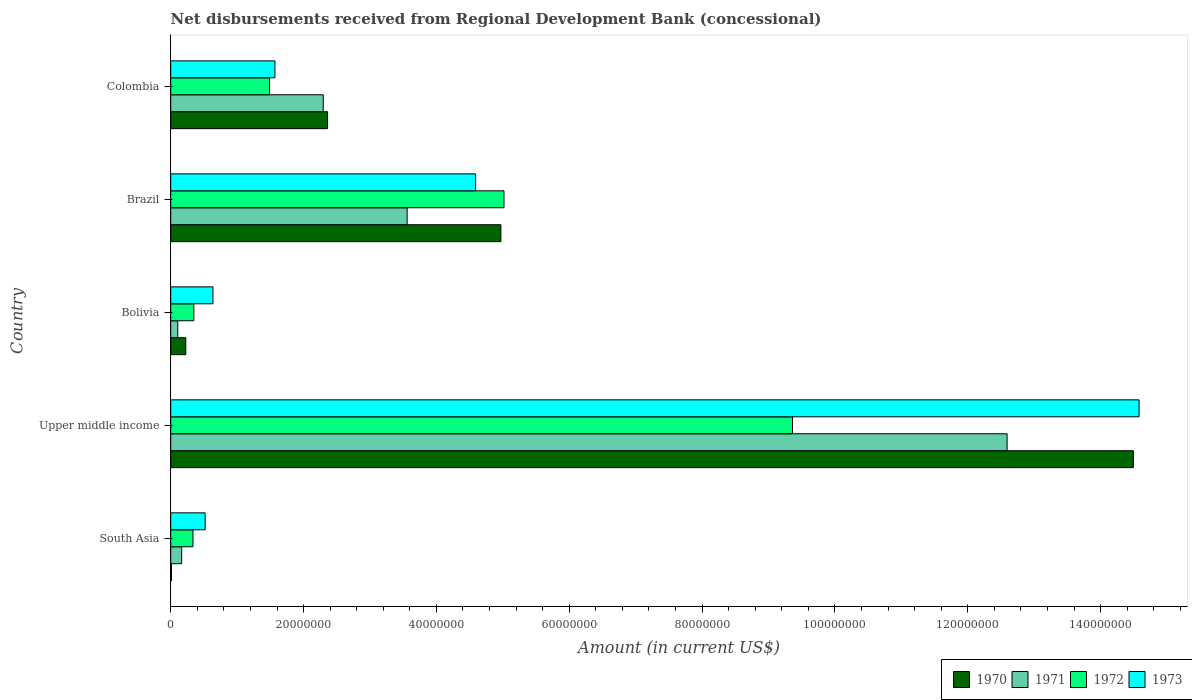Are the number of bars per tick equal to the number of legend labels?
Provide a succinct answer. Yes. Are the number of bars on each tick of the Y-axis equal?
Your answer should be very brief. Yes. What is the label of the 4th group of bars from the top?
Keep it short and to the point. Upper middle income. In how many cases, is the number of bars for a given country not equal to the number of legend labels?
Offer a very short reply. 0. What is the amount of disbursements received from Regional Development Bank in 1970 in Colombia?
Offer a terse response. 2.36e+07. Across all countries, what is the maximum amount of disbursements received from Regional Development Bank in 1970?
Your answer should be compact. 1.45e+08. Across all countries, what is the minimum amount of disbursements received from Regional Development Bank in 1971?
Offer a terse response. 1.06e+06. In which country was the amount of disbursements received from Regional Development Bank in 1973 maximum?
Ensure brevity in your answer.  Upper middle income. What is the total amount of disbursements received from Regional Development Bank in 1973 in the graph?
Keep it short and to the point. 2.19e+08. What is the difference between the amount of disbursements received from Regional Development Bank in 1970 in Bolivia and that in Brazil?
Provide a short and direct response. -4.74e+07. What is the difference between the amount of disbursements received from Regional Development Bank in 1971 in South Asia and the amount of disbursements received from Regional Development Bank in 1972 in Colombia?
Make the answer very short. -1.32e+07. What is the average amount of disbursements received from Regional Development Bank in 1972 per country?
Offer a terse response. 3.31e+07. What is the difference between the amount of disbursements received from Regional Development Bank in 1970 and amount of disbursements received from Regional Development Bank in 1972 in Brazil?
Your response must be concise. -4.68e+05. In how many countries, is the amount of disbursements received from Regional Development Bank in 1970 greater than 72000000 US$?
Provide a short and direct response. 1. What is the ratio of the amount of disbursements received from Regional Development Bank in 1971 in Colombia to that in Upper middle income?
Ensure brevity in your answer.  0.18. Is the amount of disbursements received from Regional Development Bank in 1970 in Bolivia less than that in Brazil?
Offer a terse response. Yes. What is the difference between the highest and the second highest amount of disbursements received from Regional Development Bank in 1970?
Your answer should be compact. 9.52e+07. What is the difference between the highest and the lowest amount of disbursements received from Regional Development Bank in 1971?
Your response must be concise. 1.25e+08. Is the sum of the amount of disbursements received from Regional Development Bank in 1973 in South Asia and Upper middle income greater than the maximum amount of disbursements received from Regional Development Bank in 1971 across all countries?
Keep it short and to the point. Yes. Is it the case that in every country, the sum of the amount of disbursements received from Regional Development Bank in 1971 and amount of disbursements received from Regional Development Bank in 1972 is greater than the sum of amount of disbursements received from Regional Development Bank in 1973 and amount of disbursements received from Regional Development Bank in 1970?
Provide a short and direct response. No. What does the 4th bar from the top in Brazil represents?
Make the answer very short. 1970. How many bars are there?
Ensure brevity in your answer.  20. Are all the bars in the graph horizontal?
Your response must be concise. Yes. How many countries are there in the graph?
Provide a succinct answer. 5. Does the graph contain any zero values?
Give a very brief answer. No. How many legend labels are there?
Offer a very short reply. 4. How are the legend labels stacked?
Your response must be concise. Horizontal. What is the title of the graph?
Ensure brevity in your answer.  Net disbursements received from Regional Development Bank (concessional). Does "1983" appear as one of the legend labels in the graph?
Provide a succinct answer. No. What is the label or title of the Y-axis?
Offer a very short reply. Country. What is the Amount (in current US$) of 1970 in South Asia?
Give a very brief answer. 1.09e+05. What is the Amount (in current US$) of 1971 in South Asia?
Make the answer very short. 1.65e+06. What is the Amount (in current US$) in 1972 in South Asia?
Ensure brevity in your answer.  3.35e+06. What is the Amount (in current US$) of 1973 in South Asia?
Offer a very short reply. 5.18e+06. What is the Amount (in current US$) of 1970 in Upper middle income?
Ensure brevity in your answer.  1.45e+08. What is the Amount (in current US$) in 1971 in Upper middle income?
Offer a terse response. 1.26e+08. What is the Amount (in current US$) of 1972 in Upper middle income?
Provide a succinct answer. 9.36e+07. What is the Amount (in current US$) in 1973 in Upper middle income?
Offer a very short reply. 1.46e+08. What is the Amount (in current US$) of 1970 in Bolivia?
Ensure brevity in your answer.  2.27e+06. What is the Amount (in current US$) of 1971 in Bolivia?
Keep it short and to the point. 1.06e+06. What is the Amount (in current US$) in 1972 in Bolivia?
Your answer should be compact. 3.48e+06. What is the Amount (in current US$) of 1973 in Bolivia?
Your answer should be very brief. 6.36e+06. What is the Amount (in current US$) in 1970 in Brazil?
Provide a succinct answer. 4.97e+07. What is the Amount (in current US$) in 1971 in Brazil?
Your answer should be compact. 3.56e+07. What is the Amount (in current US$) in 1972 in Brazil?
Make the answer very short. 5.02e+07. What is the Amount (in current US$) of 1973 in Brazil?
Ensure brevity in your answer.  4.59e+07. What is the Amount (in current US$) of 1970 in Colombia?
Your response must be concise. 2.36e+07. What is the Amount (in current US$) of 1971 in Colombia?
Your response must be concise. 2.30e+07. What is the Amount (in current US$) of 1972 in Colombia?
Your answer should be very brief. 1.49e+07. What is the Amount (in current US$) in 1973 in Colombia?
Offer a very short reply. 1.57e+07. Across all countries, what is the maximum Amount (in current US$) in 1970?
Your answer should be compact. 1.45e+08. Across all countries, what is the maximum Amount (in current US$) in 1971?
Ensure brevity in your answer.  1.26e+08. Across all countries, what is the maximum Amount (in current US$) of 1972?
Your response must be concise. 9.36e+07. Across all countries, what is the maximum Amount (in current US$) of 1973?
Your response must be concise. 1.46e+08. Across all countries, what is the minimum Amount (in current US$) of 1970?
Your answer should be very brief. 1.09e+05. Across all countries, what is the minimum Amount (in current US$) in 1971?
Offer a very short reply. 1.06e+06. Across all countries, what is the minimum Amount (in current US$) of 1972?
Provide a short and direct response. 3.35e+06. Across all countries, what is the minimum Amount (in current US$) of 1973?
Your answer should be compact. 5.18e+06. What is the total Amount (in current US$) in 1970 in the graph?
Provide a short and direct response. 2.21e+08. What is the total Amount (in current US$) of 1971 in the graph?
Give a very brief answer. 1.87e+08. What is the total Amount (in current US$) of 1972 in the graph?
Your answer should be very brief. 1.65e+08. What is the total Amount (in current US$) in 1973 in the graph?
Offer a very short reply. 2.19e+08. What is the difference between the Amount (in current US$) in 1970 in South Asia and that in Upper middle income?
Ensure brevity in your answer.  -1.45e+08. What is the difference between the Amount (in current US$) in 1971 in South Asia and that in Upper middle income?
Keep it short and to the point. -1.24e+08. What is the difference between the Amount (in current US$) in 1972 in South Asia and that in Upper middle income?
Keep it short and to the point. -9.03e+07. What is the difference between the Amount (in current US$) of 1973 in South Asia and that in Upper middle income?
Give a very brief answer. -1.41e+08. What is the difference between the Amount (in current US$) in 1970 in South Asia and that in Bolivia?
Make the answer very short. -2.16e+06. What is the difference between the Amount (in current US$) of 1971 in South Asia and that in Bolivia?
Your answer should be compact. 5.92e+05. What is the difference between the Amount (in current US$) of 1973 in South Asia and that in Bolivia?
Make the answer very short. -1.18e+06. What is the difference between the Amount (in current US$) in 1970 in South Asia and that in Brazil?
Provide a short and direct response. -4.96e+07. What is the difference between the Amount (in current US$) of 1971 in South Asia and that in Brazil?
Your answer should be compact. -3.39e+07. What is the difference between the Amount (in current US$) of 1972 in South Asia and that in Brazil?
Offer a terse response. -4.68e+07. What is the difference between the Amount (in current US$) of 1973 in South Asia and that in Brazil?
Your answer should be compact. -4.07e+07. What is the difference between the Amount (in current US$) in 1970 in South Asia and that in Colombia?
Your answer should be very brief. -2.35e+07. What is the difference between the Amount (in current US$) of 1971 in South Asia and that in Colombia?
Make the answer very short. -2.13e+07. What is the difference between the Amount (in current US$) in 1972 in South Asia and that in Colombia?
Keep it short and to the point. -1.15e+07. What is the difference between the Amount (in current US$) of 1973 in South Asia and that in Colombia?
Your answer should be very brief. -1.05e+07. What is the difference between the Amount (in current US$) of 1970 in Upper middle income and that in Bolivia?
Provide a short and direct response. 1.43e+08. What is the difference between the Amount (in current US$) in 1971 in Upper middle income and that in Bolivia?
Your answer should be compact. 1.25e+08. What is the difference between the Amount (in current US$) in 1972 in Upper middle income and that in Bolivia?
Provide a succinct answer. 9.01e+07. What is the difference between the Amount (in current US$) in 1973 in Upper middle income and that in Bolivia?
Your response must be concise. 1.39e+08. What is the difference between the Amount (in current US$) of 1970 in Upper middle income and that in Brazil?
Ensure brevity in your answer.  9.52e+07. What is the difference between the Amount (in current US$) of 1971 in Upper middle income and that in Brazil?
Keep it short and to the point. 9.03e+07. What is the difference between the Amount (in current US$) of 1972 in Upper middle income and that in Brazil?
Provide a short and direct response. 4.34e+07. What is the difference between the Amount (in current US$) of 1973 in Upper middle income and that in Brazil?
Ensure brevity in your answer.  9.99e+07. What is the difference between the Amount (in current US$) of 1970 in Upper middle income and that in Colombia?
Offer a very short reply. 1.21e+08. What is the difference between the Amount (in current US$) of 1971 in Upper middle income and that in Colombia?
Keep it short and to the point. 1.03e+08. What is the difference between the Amount (in current US$) in 1972 in Upper middle income and that in Colombia?
Provide a succinct answer. 7.87e+07. What is the difference between the Amount (in current US$) of 1973 in Upper middle income and that in Colombia?
Your answer should be very brief. 1.30e+08. What is the difference between the Amount (in current US$) of 1970 in Bolivia and that in Brazil?
Offer a very short reply. -4.74e+07. What is the difference between the Amount (in current US$) in 1971 in Bolivia and that in Brazil?
Your answer should be compact. -3.45e+07. What is the difference between the Amount (in current US$) of 1972 in Bolivia and that in Brazil?
Provide a short and direct response. -4.67e+07. What is the difference between the Amount (in current US$) of 1973 in Bolivia and that in Brazil?
Make the answer very short. -3.95e+07. What is the difference between the Amount (in current US$) in 1970 in Bolivia and that in Colombia?
Offer a terse response. -2.13e+07. What is the difference between the Amount (in current US$) of 1971 in Bolivia and that in Colombia?
Your response must be concise. -2.19e+07. What is the difference between the Amount (in current US$) in 1972 in Bolivia and that in Colombia?
Offer a very short reply. -1.14e+07. What is the difference between the Amount (in current US$) of 1973 in Bolivia and that in Colombia?
Offer a terse response. -9.33e+06. What is the difference between the Amount (in current US$) in 1970 in Brazil and that in Colombia?
Make the answer very short. 2.61e+07. What is the difference between the Amount (in current US$) of 1971 in Brazil and that in Colombia?
Ensure brevity in your answer.  1.26e+07. What is the difference between the Amount (in current US$) in 1972 in Brazil and that in Colombia?
Your answer should be very brief. 3.53e+07. What is the difference between the Amount (in current US$) of 1973 in Brazil and that in Colombia?
Offer a very short reply. 3.02e+07. What is the difference between the Amount (in current US$) of 1970 in South Asia and the Amount (in current US$) of 1971 in Upper middle income?
Make the answer very short. -1.26e+08. What is the difference between the Amount (in current US$) of 1970 in South Asia and the Amount (in current US$) of 1972 in Upper middle income?
Give a very brief answer. -9.35e+07. What is the difference between the Amount (in current US$) in 1970 in South Asia and the Amount (in current US$) in 1973 in Upper middle income?
Make the answer very short. -1.46e+08. What is the difference between the Amount (in current US$) of 1971 in South Asia and the Amount (in current US$) of 1972 in Upper middle income?
Your answer should be very brief. -9.20e+07. What is the difference between the Amount (in current US$) of 1971 in South Asia and the Amount (in current US$) of 1973 in Upper middle income?
Give a very brief answer. -1.44e+08. What is the difference between the Amount (in current US$) in 1972 in South Asia and the Amount (in current US$) in 1973 in Upper middle income?
Ensure brevity in your answer.  -1.42e+08. What is the difference between the Amount (in current US$) of 1970 in South Asia and the Amount (in current US$) of 1971 in Bolivia?
Provide a short and direct response. -9.49e+05. What is the difference between the Amount (in current US$) in 1970 in South Asia and the Amount (in current US$) in 1972 in Bolivia?
Your answer should be compact. -3.37e+06. What is the difference between the Amount (in current US$) of 1970 in South Asia and the Amount (in current US$) of 1973 in Bolivia?
Provide a succinct answer. -6.25e+06. What is the difference between the Amount (in current US$) in 1971 in South Asia and the Amount (in current US$) in 1972 in Bolivia?
Provide a short and direct response. -1.83e+06. What is the difference between the Amount (in current US$) of 1971 in South Asia and the Amount (in current US$) of 1973 in Bolivia?
Offer a terse response. -4.71e+06. What is the difference between the Amount (in current US$) of 1972 in South Asia and the Amount (in current US$) of 1973 in Bolivia?
Ensure brevity in your answer.  -3.01e+06. What is the difference between the Amount (in current US$) of 1970 in South Asia and the Amount (in current US$) of 1971 in Brazil?
Your response must be concise. -3.55e+07. What is the difference between the Amount (in current US$) in 1970 in South Asia and the Amount (in current US$) in 1972 in Brazil?
Provide a succinct answer. -5.01e+07. What is the difference between the Amount (in current US$) in 1970 in South Asia and the Amount (in current US$) in 1973 in Brazil?
Offer a terse response. -4.58e+07. What is the difference between the Amount (in current US$) of 1971 in South Asia and the Amount (in current US$) of 1972 in Brazil?
Offer a very short reply. -4.85e+07. What is the difference between the Amount (in current US$) of 1971 in South Asia and the Amount (in current US$) of 1973 in Brazil?
Provide a short and direct response. -4.43e+07. What is the difference between the Amount (in current US$) in 1972 in South Asia and the Amount (in current US$) in 1973 in Brazil?
Provide a short and direct response. -4.26e+07. What is the difference between the Amount (in current US$) in 1970 in South Asia and the Amount (in current US$) in 1971 in Colombia?
Ensure brevity in your answer.  -2.29e+07. What is the difference between the Amount (in current US$) in 1970 in South Asia and the Amount (in current US$) in 1972 in Colombia?
Your response must be concise. -1.48e+07. What is the difference between the Amount (in current US$) of 1970 in South Asia and the Amount (in current US$) of 1973 in Colombia?
Your answer should be very brief. -1.56e+07. What is the difference between the Amount (in current US$) of 1971 in South Asia and the Amount (in current US$) of 1972 in Colombia?
Ensure brevity in your answer.  -1.32e+07. What is the difference between the Amount (in current US$) in 1971 in South Asia and the Amount (in current US$) in 1973 in Colombia?
Ensure brevity in your answer.  -1.40e+07. What is the difference between the Amount (in current US$) in 1972 in South Asia and the Amount (in current US$) in 1973 in Colombia?
Provide a succinct answer. -1.23e+07. What is the difference between the Amount (in current US$) of 1970 in Upper middle income and the Amount (in current US$) of 1971 in Bolivia?
Offer a very short reply. 1.44e+08. What is the difference between the Amount (in current US$) in 1970 in Upper middle income and the Amount (in current US$) in 1972 in Bolivia?
Your answer should be very brief. 1.41e+08. What is the difference between the Amount (in current US$) in 1970 in Upper middle income and the Amount (in current US$) in 1973 in Bolivia?
Make the answer very short. 1.39e+08. What is the difference between the Amount (in current US$) in 1971 in Upper middle income and the Amount (in current US$) in 1972 in Bolivia?
Your response must be concise. 1.22e+08. What is the difference between the Amount (in current US$) of 1971 in Upper middle income and the Amount (in current US$) of 1973 in Bolivia?
Make the answer very short. 1.20e+08. What is the difference between the Amount (in current US$) of 1972 in Upper middle income and the Amount (in current US$) of 1973 in Bolivia?
Offer a terse response. 8.72e+07. What is the difference between the Amount (in current US$) of 1970 in Upper middle income and the Amount (in current US$) of 1971 in Brazil?
Your answer should be very brief. 1.09e+08. What is the difference between the Amount (in current US$) of 1970 in Upper middle income and the Amount (in current US$) of 1972 in Brazil?
Give a very brief answer. 9.48e+07. What is the difference between the Amount (in current US$) of 1970 in Upper middle income and the Amount (in current US$) of 1973 in Brazil?
Offer a very short reply. 9.90e+07. What is the difference between the Amount (in current US$) of 1971 in Upper middle income and the Amount (in current US$) of 1972 in Brazil?
Provide a succinct answer. 7.57e+07. What is the difference between the Amount (in current US$) in 1971 in Upper middle income and the Amount (in current US$) in 1973 in Brazil?
Your answer should be compact. 8.00e+07. What is the difference between the Amount (in current US$) in 1972 in Upper middle income and the Amount (in current US$) in 1973 in Brazil?
Make the answer very short. 4.77e+07. What is the difference between the Amount (in current US$) of 1970 in Upper middle income and the Amount (in current US$) of 1971 in Colombia?
Give a very brief answer. 1.22e+08. What is the difference between the Amount (in current US$) in 1970 in Upper middle income and the Amount (in current US$) in 1972 in Colombia?
Give a very brief answer. 1.30e+08. What is the difference between the Amount (in current US$) in 1970 in Upper middle income and the Amount (in current US$) in 1973 in Colombia?
Your answer should be very brief. 1.29e+08. What is the difference between the Amount (in current US$) in 1971 in Upper middle income and the Amount (in current US$) in 1972 in Colombia?
Offer a terse response. 1.11e+08. What is the difference between the Amount (in current US$) of 1971 in Upper middle income and the Amount (in current US$) of 1973 in Colombia?
Offer a very short reply. 1.10e+08. What is the difference between the Amount (in current US$) in 1972 in Upper middle income and the Amount (in current US$) in 1973 in Colombia?
Ensure brevity in your answer.  7.79e+07. What is the difference between the Amount (in current US$) in 1970 in Bolivia and the Amount (in current US$) in 1971 in Brazil?
Offer a terse response. -3.33e+07. What is the difference between the Amount (in current US$) of 1970 in Bolivia and the Amount (in current US$) of 1972 in Brazil?
Give a very brief answer. -4.79e+07. What is the difference between the Amount (in current US$) in 1970 in Bolivia and the Amount (in current US$) in 1973 in Brazil?
Make the answer very short. -4.36e+07. What is the difference between the Amount (in current US$) in 1971 in Bolivia and the Amount (in current US$) in 1972 in Brazil?
Make the answer very short. -4.91e+07. What is the difference between the Amount (in current US$) in 1971 in Bolivia and the Amount (in current US$) in 1973 in Brazil?
Give a very brief answer. -4.49e+07. What is the difference between the Amount (in current US$) of 1972 in Bolivia and the Amount (in current US$) of 1973 in Brazil?
Your answer should be very brief. -4.24e+07. What is the difference between the Amount (in current US$) of 1970 in Bolivia and the Amount (in current US$) of 1971 in Colombia?
Ensure brevity in your answer.  -2.07e+07. What is the difference between the Amount (in current US$) of 1970 in Bolivia and the Amount (in current US$) of 1972 in Colombia?
Ensure brevity in your answer.  -1.26e+07. What is the difference between the Amount (in current US$) in 1970 in Bolivia and the Amount (in current US$) in 1973 in Colombia?
Give a very brief answer. -1.34e+07. What is the difference between the Amount (in current US$) of 1971 in Bolivia and the Amount (in current US$) of 1972 in Colombia?
Your answer should be compact. -1.38e+07. What is the difference between the Amount (in current US$) in 1971 in Bolivia and the Amount (in current US$) in 1973 in Colombia?
Make the answer very short. -1.46e+07. What is the difference between the Amount (in current US$) in 1972 in Bolivia and the Amount (in current US$) in 1973 in Colombia?
Ensure brevity in your answer.  -1.22e+07. What is the difference between the Amount (in current US$) in 1970 in Brazil and the Amount (in current US$) in 1971 in Colombia?
Provide a succinct answer. 2.67e+07. What is the difference between the Amount (in current US$) in 1970 in Brazil and the Amount (in current US$) in 1972 in Colombia?
Your response must be concise. 3.48e+07. What is the difference between the Amount (in current US$) in 1970 in Brazil and the Amount (in current US$) in 1973 in Colombia?
Ensure brevity in your answer.  3.40e+07. What is the difference between the Amount (in current US$) of 1971 in Brazil and the Amount (in current US$) of 1972 in Colombia?
Give a very brief answer. 2.07e+07. What is the difference between the Amount (in current US$) in 1971 in Brazil and the Amount (in current US$) in 1973 in Colombia?
Provide a short and direct response. 1.99e+07. What is the difference between the Amount (in current US$) of 1972 in Brazil and the Amount (in current US$) of 1973 in Colombia?
Offer a very short reply. 3.45e+07. What is the average Amount (in current US$) of 1970 per country?
Your answer should be very brief. 4.41e+07. What is the average Amount (in current US$) in 1971 per country?
Ensure brevity in your answer.  3.74e+07. What is the average Amount (in current US$) in 1972 per country?
Your answer should be compact. 3.31e+07. What is the average Amount (in current US$) in 1973 per country?
Your response must be concise. 4.38e+07. What is the difference between the Amount (in current US$) in 1970 and Amount (in current US$) in 1971 in South Asia?
Give a very brief answer. -1.54e+06. What is the difference between the Amount (in current US$) of 1970 and Amount (in current US$) of 1972 in South Asia?
Make the answer very short. -3.24e+06. What is the difference between the Amount (in current US$) in 1970 and Amount (in current US$) in 1973 in South Asia?
Offer a very short reply. -5.08e+06. What is the difference between the Amount (in current US$) in 1971 and Amount (in current US$) in 1972 in South Asia?
Make the answer very short. -1.70e+06. What is the difference between the Amount (in current US$) of 1971 and Amount (in current US$) of 1973 in South Asia?
Your answer should be compact. -3.53e+06. What is the difference between the Amount (in current US$) in 1972 and Amount (in current US$) in 1973 in South Asia?
Keep it short and to the point. -1.83e+06. What is the difference between the Amount (in current US$) in 1970 and Amount (in current US$) in 1971 in Upper middle income?
Make the answer very short. 1.90e+07. What is the difference between the Amount (in current US$) in 1970 and Amount (in current US$) in 1972 in Upper middle income?
Provide a succinct answer. 5.13e+07. What is the difference between the Amount (in current US$) of 1970 and Amount (in current US$) of 1973 in Upper middle income?
Your answer should be very brief. -8.58e+05. What is the difference between the Amount (in current US$) of 1971 and Amount (in current US$) of 1972 in Upper middle income?
Provide a short and direct response. 3.23e+07. What is the difference between the Amount (in current US$) in 1971 and Amount (in current US$) in 1973 in Upper middle income?
Offer a terse response. -1.99e+07. What is the difference between the Amount (in current US$) in 1972 and Amount (in current US$) in 1973 in Upper middle income?
Ensure brevity in your answer.  -5.22e+07. What is the difference between the Amount (in current US$) in 1970 and Amount (in current US$) in 1971 in Bolivia?
Your answer should be very brief. 1.21e+06. What is the difference between the Amount (in current US$) in 1970 and Amount (in current US$) in 1972 in Bolivia?
Provide a succinct answer. -1.21e+06. What is the difference between the Amount (in current US$) of 1970 and Amount (in current US$) of 1973 in Bolivia?
Your answer should be compact. -4.09e+06. What is the difference between the Amount (in current US$) of 1971 and Amount (in current US$) of 1972 in Bolivia?
Keep it short and to the point. -2.42e+06. What is the difference between the Amount (in current US$) in 1971 and Amount (in current US$) in 1973 in Bolivia?
Keep it short and to the point. -5.30e+06. What is the difference between the Amount (in current US$) of 1972 and Amount (in current US$) of 1973 in Bolivia?
Keep it short and to the point. -2.88e+06. What is the difference between the Amount (in current US$) of 1970 and Amount (in current US$) of 1971 in Brazil?
Provide a succinct answer. 1.41e+07. What is the difference between the Amount (in current US$) in 1970 and Amount (in current US$) in 1972 in Brazil?
Ensure brevity in your answer.  -4.68e+05. What is the difference between the Amount (in current US$) in 1970 and Amount (in current US$) in 1973 in Brazil?
Keep it short and to the point. 3.80e+06. What is the difference between the Amount (in current US$) in 1971 and Amount (in current US$) in 1972 in Brazil?
Give a very brief answer. -1.46e+07. What is the difference between the Amount (in current US$) in 1971 and Amount (in current US$) in 1973 in Brazil?
Keep it short and to the point. -1.03e+07. What is the difference between the Amount (in current US$) in 1972 and Amount (in current US$) in 1973 in Brazil?
Make the answer very short. 4.27e+06. What is the difference between the Amount (in current US$) of 1970 and Amount (in current US$) of 1971 in Colombia?
Your answer should be compact. 6.52e+05. What is the difference between the Amount (in current US$) of 1970 and Amount (in current US$) of 1972 in Colombia?
Your response must be concise. 8.74e+06. What is the difference between the Amount (in current US$) in 1970 and Amount (in current US$) in 1973 in Colombia?
Give a very brief answer. 7.93e+06. What is the difference between the Amount (in current US$) in 1971 and Amount (in current US$) in 1972 in Colombia?
Make the answer very short. 8.08e+06. What is the difference between the Amount (in current US$) in 1971 and Amount (in current US$) in 1973 in Colombia?
Keep it short and to the point. 7.28e+06. What is the difference between the Amount (in current US$) of 1972 and Amount (in current US$) of 1973 in Colombia?
Give a very brief answer. -8.09e+05. What is the ratio of the Amount (in current US$) of 1970 in South Asia to that in Upper middle income?
Provide a succinct answer. 0. What is the ratio of the Amount (in current US$) in 1971 in South Asia to that in Upper middle income?
Your response must be concise. 0.01. What is the ratio of the Amount (in current US$) of 1972 in South Asia to that in Upper middle income?
Give a very brief answer. 0.04. What is the ratio of the Amount (in current US$) of 1973 in South Asia to that in Upper middle income?
Your response must be concise. 0.04. What is the ratio of the Amount (in current US$) in 1970 in South Asia to that in Bolivia?
Offer a very short reply. 0.05. What is the ratio of the Amount (in current US$) of 1971 in South Asia to that in Bolivia?
Keep it short and to the point. 1.56. What is the ratio of the Amount (in current US$) in 1972 in South Asia to that in Bolivia?
Your response must be concise. 0.96. What is the ratio of the Amount (in current US$) in 1973 in South Asia to that in Bolivia?
Ensure brevity in your answer.  0.82. What is the ratio of the Amount (in current US$) of 1970 in South Asia to that in Brazil?
Your answer should be compact. 0. What is the ratio of the Amount (in current US$) in 1971 in South Asia to that in Brazil?
Provide a short and direct response. 0.05. What is the ratio of the Amount (in current US$) in 1972 in South Asia to that in Brazil?
Offer a terse response. 0.07. What is the ratio of the Amount (in current US$) of 1973 in South Asia to that in Brazil?
Give a very brief answer. 0.11. What is the ratio of the Amount (in current US$) in 1970 in South Asia to that in Colombia?
Give a very brief answer. 0. What is the ratio of the Amount (in current US$) in 1971 in South Asia to that in Colombia?
Keep it short and to the point. 0.07. What is the ratio of the Amount (in current US$) of 1972 in South Asia to that in Colombia?
Your answer should be very brief. 0.23. What is the ratio of the Amount (in current US$) in 1973 in South Asia to that in Colombia?
Your response must be concise. 0.33. What is the ratio of the Amount (in current US$) of 1970 in Upper middle income to that in Bolivia?
Keep it short and to the point. 63.85. What is the ratio of the Amount (in current US$) of 1971 in Upper middle income to that in Bolivia?
Your answer should be very brief. 119.02. What is the ratio of the Amount (in current US$) of 1972 in Upper middle income to that in Bolivia?
Keep it short and to the point. 26.9. What is the ratio of the Amount (in current US$) in 1973 in Upper middle income to that in Bolivia?
Provide a short and direct response. 22.92. What is the ratio of the Amount (in current US$) of 1970 in Upper middle income to that in Brazil?
Your response must be concise. 2.92. What is the ratio of the Amount (in current US$) of 1971 in Upper middle income to that in Brazil?
Your response must be concise. 3.54. What is the ratio of the Amount (in current US$) in 1972 in Upper middle income to that in Brazil?
Offer a terse response. 1.87. What is the ratio of the Amount (in current US$) of 1973 in Upper middle income to that in Brazil?
Give a very brief answer. 3.18. What is the ratio of the Amount (in current US$) in 1970 in Upper middle income to that in Colombia?
Give a very brief answer. 6.14. What is the ratio of the Amount (in current US$) in 1971 in Upper middle income to that in Colombia?
Give a very brief answer. 5.48. What is the ratio of the Amount (in current US$) in 1972 in Upper middle income to that in Colombia?
Give a very brief answer. 6.29. What is the ratio of the Amount (in current US$) of 1973 in Upper middle income to that in Colombia?
Your answer should be compact. 9.29. What is the ratio of the Amount (in current US$) of 1970 in Bolivia to that in Brazil?
Your answer should be very brief. 0.05. What is the ratio of the Amount (in current US$) in 1971 in Bolivia to that in Brazil?
Your answer should be compact. 0.03. What is the ratio of the Amount (in current US$) in 1972 in Bolivia to that in Brazil?
Your answer should be very brief. 0.07. What is the ratio of the Amount (in current US$) of 1973 in Bolivia to that in Brazil?
Offer a very short reply. 0.14. What is the ratio of the Amount (in current US$) in 1970 in Bolivia to that in Colombia?
Offer a very short reply. 0.1. What is the ratio of the Amount (in current US$) of 1971 in Bolivia to that in Colombia?
Ensure brevity in your answer.  0.05. What is the ratio of the Amount (in current US$) of 1972 in Bolivia to that in Colombia?
Your response must be concise. 0.23. What is the ratio of the Amount (in current US$) of 1973 in Bolivia to that in Colombia?
Your answer should be compact. 0.41. What is the ratio of the Amount (in current US$) of 1970 in Brazil to that in Colombia?
Keep it short and to the point. 2.1. What is the ratio of the Amount (in current US$) in 1971 in Brazil to that in Colombia?
Give a very brief answer. 1.55. What is the ratio of the Amount (in current US$) in 1972 in Brazil to that in Colombia?
Offer a terse response. 3.37. What is the ratio of the Amount (in current US$) of 1973 in Brazil to that in Colombia?
Provide a succinct answer. 2.93. What is the difference between the highest and the second highest Amount (in current US$) in 1970?
Your answer should be compact. 9.52e+07. What is the difference between the highest and the second highest Amount (in current US$) in 1971?
Offer a very short reply. 9.03e+07. What is the difference between the highest and the second highest Amount (in current US$) in 1972?
Make the answer very short. 4.34e+07. What is the difference between the highest and the second highest Amount (in current US$) in 1973?
Keep it short and to the point. 9.99e+07. What is the difference between the highest and the lowest Amount (in current US$) in 1970?
Your answer should be compact. 1.45e+08. What is the difference between the highest and the lowest Amount (in current US$) of 1971?
Provide a short and direct response. 1.25e+08. What is the difference between the highest and the lowest Amount (in current US$) in 1972?
Offer a terse response. 9.03e+07. What is the difference between the highest and the lowest Amount (in current US$) of 1973?
Provide a succinct answer. 1.41e+08. 